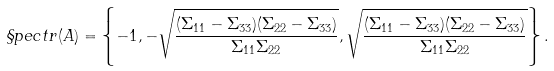Convert formula to latex. <formula><loc_0><loc_0><loc_500><loc_500>\S p e c t r ( A ) = \left \{ - 1 , - \sqrt { \frac { ( \Sigma _ { 1 1 } - \Sigma _ { 3 3 } ) ( \Sigma _ { 2 2 } - \Sigma _ { 3 3 } ) } { \Sigma _ { 1 1 } \Sigma _ { 2 2 } } } , \sqrt { \frac { ( \Sigma _ { 1 1 } - \Sigma _ { 3 3 } ) ( \Sigma _ { 2 2 } - \Sigma _ { 3 3 } ) } { \Sigma _ { 1 1 } \Sigma _ { 2 2 } } } \right \} .</formula> 